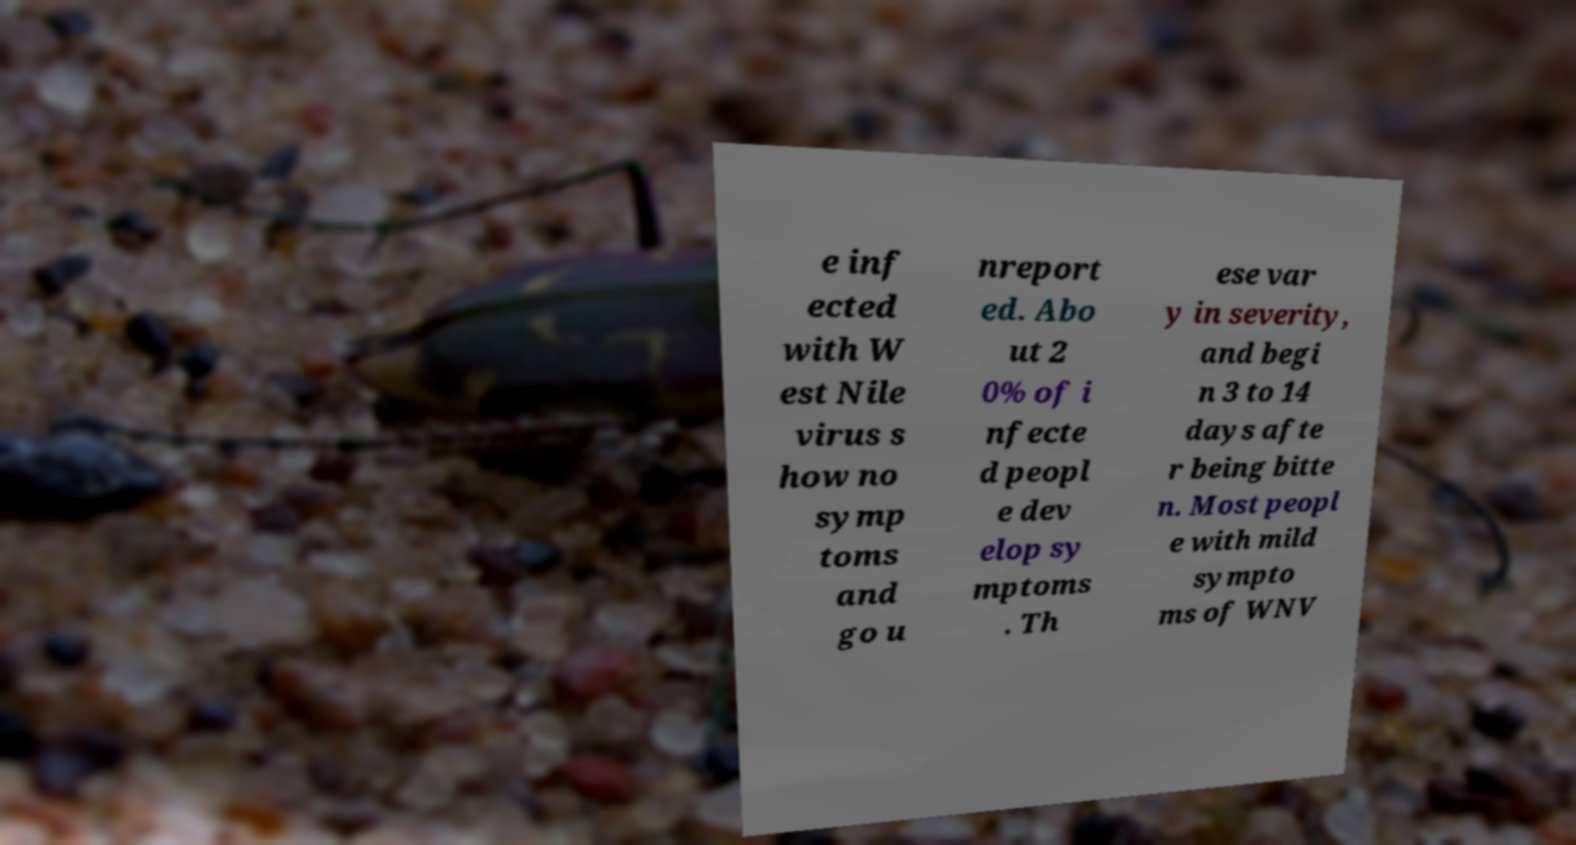For documentation purposes, I need the text within this image transcribed. Could you provide that? e inf ected with W est Nile virus s how no symp toms and go u nreport ed. Abo ut 2 0% of i nfecte d peopl e dev elop sy mptoms . Th ese var y in severity, and begi n 3 to 14 days afte r being bitte n. Most peopl e with mild sympto ms of WNV 